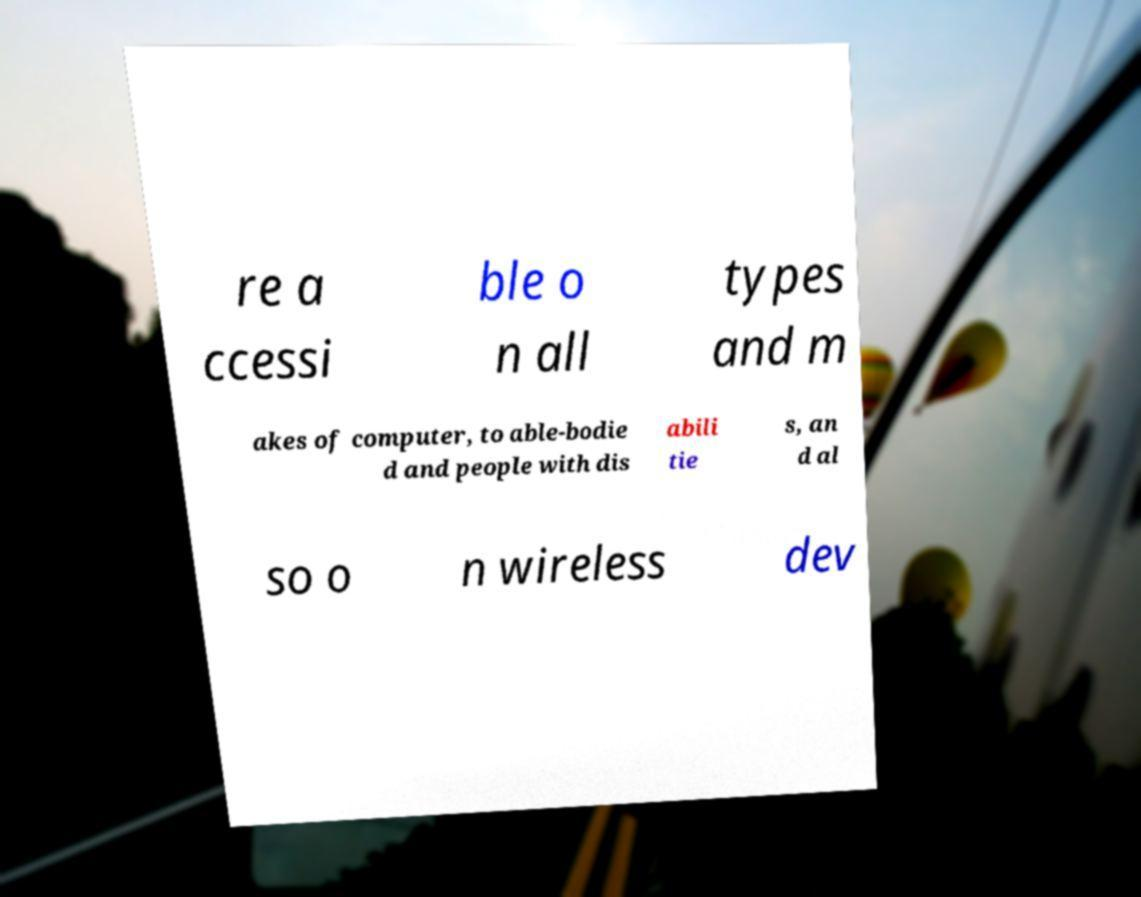I need the written content from this picture converted into text. Can you do that? re a ccessi ble o n all types and m akes of computer, to able-bodie d and people with dis abili tie s, an d al so o n wireless dev 